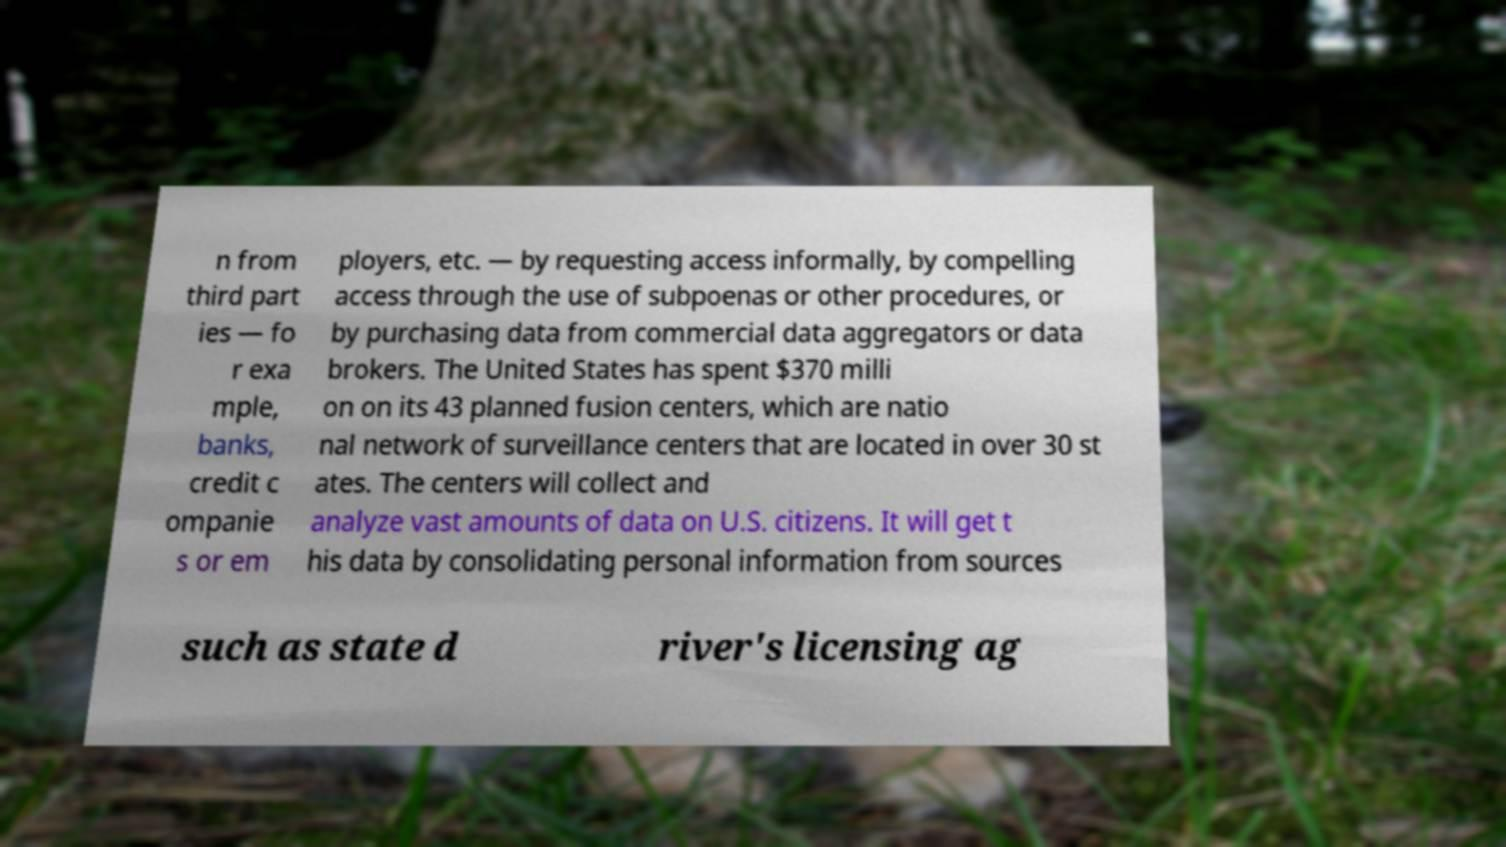Can you accurately transcribe the text from the provided image for me? n from third part ies — fo r exa mple, banks, credit c ompanie s or em ployers, etc. — by requesting access informally, by compelling access through the use of subpoenas or other procedures, or by purchasing data from commercial data aggregators or data brokers. The United States has spent $370 milli on on its 43 planned fusion centers, which are natio nal network of surveillance centers that are located in over 30 st ates. The centers will collect and analyze vast amounts of data on U.S. citizens. It will get t his data by consolidating personal information from sources such as state d river's licensing ag 